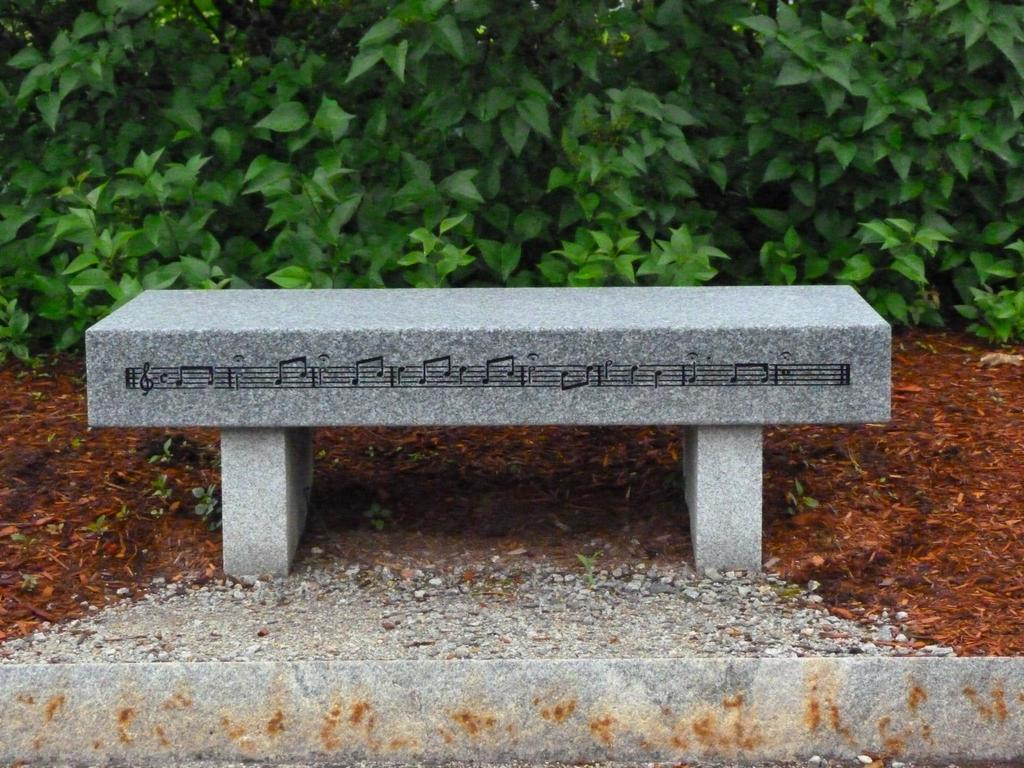What type of seating is present in the image? There is a bench in the image. What is written or drawn on the bench? There are music symbols on the bench. What can be seen in the background of the image? There are trees visible in the background. What is present at the bottom of the image? There is mud at the bottom of the image. What type of vegetation is in the image? There are plants in the image. What type of material is present in the image? There are stones in the image. Where is the baby sitting on the bench in the image? There is no baby present in the image; it only features a bench with music symbols and a background with trees. 